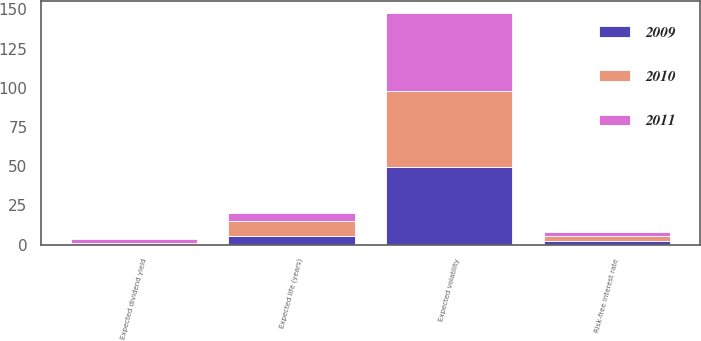<chart> <loc_0><loc_0><loc_500><loc_500><stacked_bar_chart><ecel><fcel>Expected life (years)<fcel>Risk-free interest rate<fcel>Expected volatility<fcel>Expected dividend yield<nl><fcel>2010<fcel>9.9<fcel>3.3<fcel>48<fcel>1.3<nl><fcel>2011<fcel>5<fcel>2.2<fcel>50<fcel>2<nl><fcel>2009<fcel>5.4<fcel>2.4<fcel>49.8<fcel>0<nl></chart> 